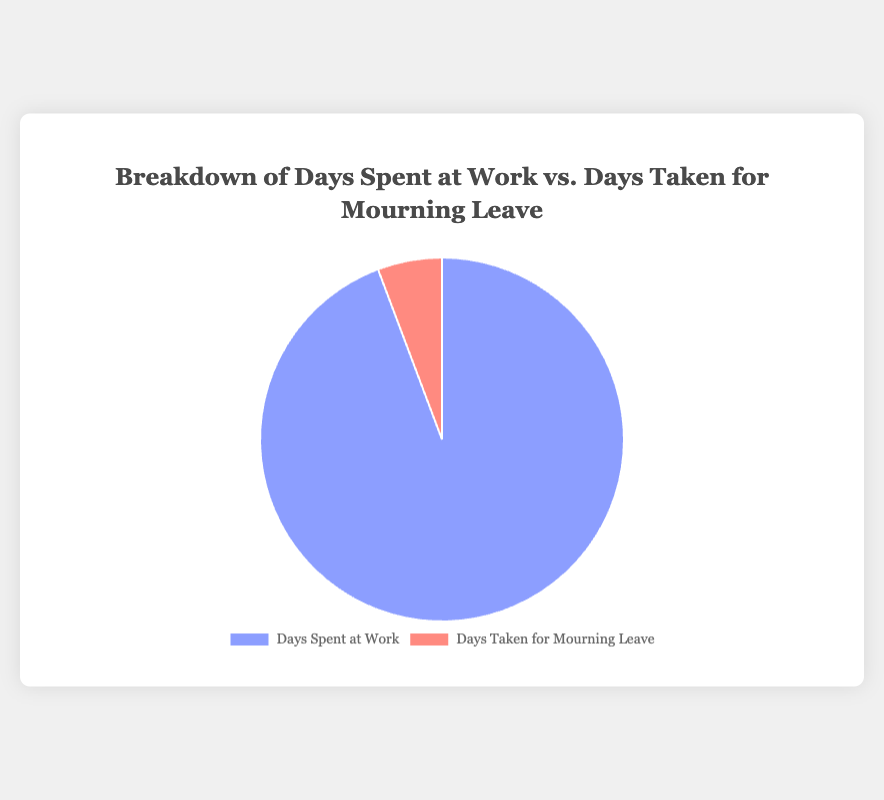What is the total number of days spent at work by Law Enforcement employees? The pie chart shows that Law Enforcement employees spent 247 days at work.
Answer: 247 How many more days did Law Enforcement employees spend at work compared to Federal Government employees? Law Enforcement employees spent 247 days at work and Federal Government employees spent 243 days. The difference is 247 - 243 = 4 days.
Answer: 4 Which group took the highest number of days for mourning leave? By looking at the chart, Law Enforcement employees took the highest number of days for mourning leave, which is 15 days.
Answer: Law Enforcement Compare the days taken for mourning leave by State Government employees and Non-Profit Workers. Who took fewer days? State Government employees took 7 days for mourning leave, while Non-Profit Workers took 8 days. Thus, State Government employees took fewer days.
Answer: State Government employees What is the total number of days spent at work by all employees combined? Adding up the days spent at work for all categories: 243 (Federal Government) + 240 (State Government) + 245 (Private Sector) + 247 (Law Enforcement) + 238 (Non-Profit) = 1213 days.
Answer: 1213 What is the average number of days taken for mourning leave across all groups? Summing the days taken for mourning leave by all groups: 10 (Federal Government) + 7 (State Government) + 5 (Private Sector) + 15 (Law Enforcement) + 8 (Non-Profit) = 45 days. The average is 45 / 5 = 9 days.
Answer: 9 How many more days did Non-Profit Workers spend at work compared to the days they took for mourning leave? Non-Profit Workers spent 238 days at work and took 8 days for mourning leave. The difference is 238 - 8 = 230 days.
Answer: 230 Which group's slice for mourning leave is larger visually, Private Sector Employees or State Government Employees? The pie chart indicates State Government Employees took 7 days and Private Sector Employees 5 days. Therefore, State Government Employees’ slice is visually larger.
Answer: State Government What is the difference in the number of days taken for mourning leave between the group with the minimum and the group with the maximum days? The minimum days for mourning leave is taken by Private Sector Employees (5 days) and the maximum is by Law Enforcement (15 days). The difference is 15 - 5 = 10 days.
Answer: 10 